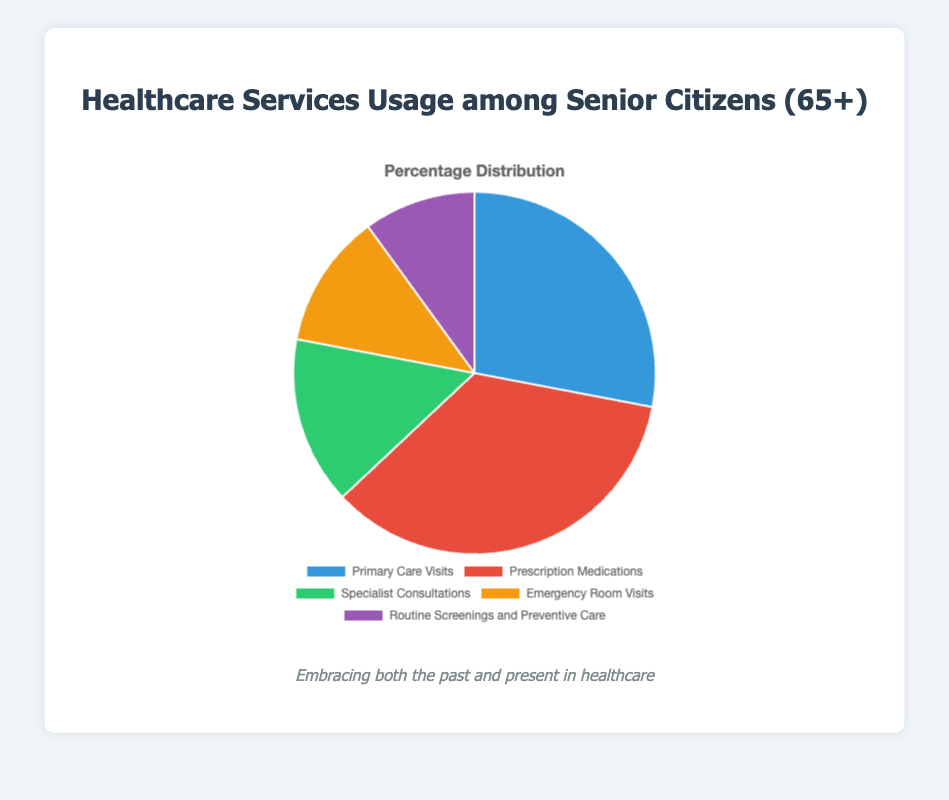Which healthcare service category has the highest usage percentage among senior citizens? By examining the pie chart, "Prescription Medications" has the largest slice.
Answer: Prescription Medications Which healthcare service category has the lowest usage percentage among senior citizens? By looking at the smallest slice in the pie chart, "Routine Screenings and Preventive Care" is the smallest.
Answer: Routine Screenings and Preventive Care What is the combined percentage usage of "Emergency Room Visits" and "Specialist Consultations"? Summing up the percentages of "Emergency Room Visits" (12%) and "Specialist Consultations" (15%), we get 12 + 15 = 27%.
Answer: 27% Is the usage percentage of "Primary Care Visits" greater than "Routine Screenings and Preventive Care"? Comparing the percentages, "Primary Care Visits" (28%) is greater than "Routine Screenings and Preventive Care" (10%).
Answer: Yes How much more usage does "Prescription Medications" have compared to "Emergency Room Visits"? Subtracting the percentage of "Emergency Room Visits" (12%) from "Prescription Medications" (35%), we get 35 - 12 = 23%.
Answer: 23% What is the percentage difference between "Primary Care Visits" and "Specialist Consultations"? Subtracting the percentage of "Specialist Consultations" (15%) from "Primary Care Visits" (28%), we get 28 - 15 = 13%.
Answer: 13% Which two categories together make up the majority of healthcare service usage? By adding the top two percentages, "Prescription Medications" (35%) and "Primary Care Visits" (28%), we get 35 + 28 = 63%, which is more than half of the total.
Answer: Prescription Medications and Primary Care Visits Which color represents "Routine Screenings and Preventive Care" in the pie chart? Observing the pie chart, the slice for "Routine Screenings and Preventive Care" is colored purple.
Answer: Purple What percentage of healthcare services is dedicated to "Primary Care Visits"? The pie chart's slice for "Primary Care Visits" represents 28% of the total.
Answer: 28% 